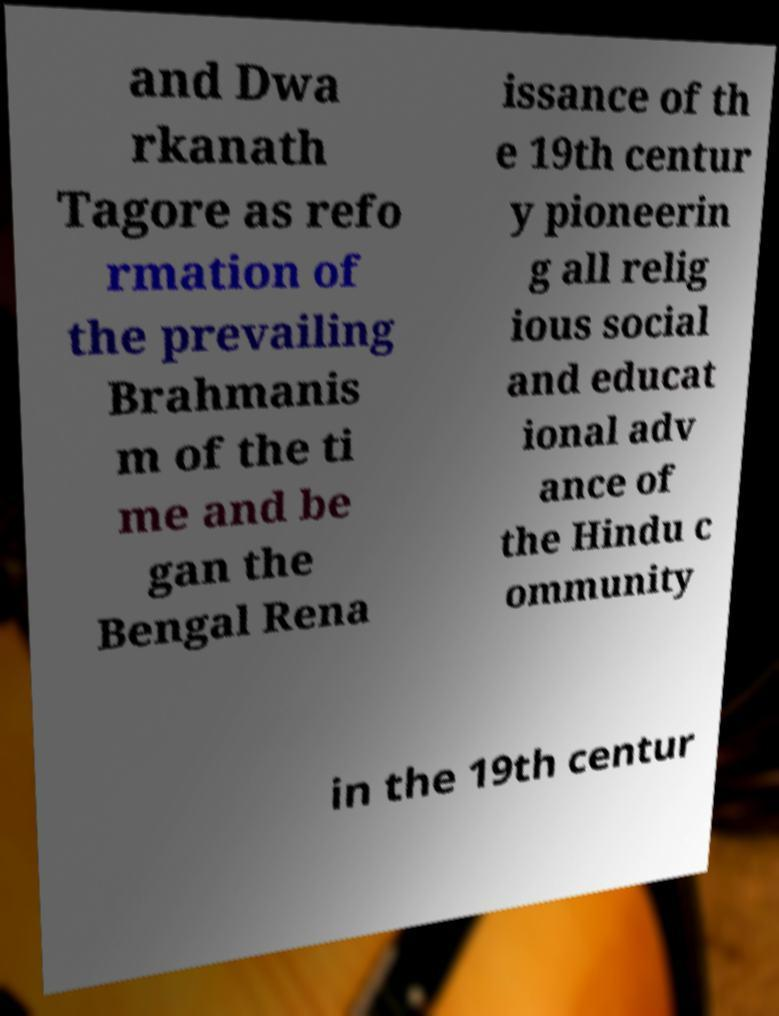Could you assist in decoding the text presented in this image and type it out clearly? and Dwa rkanath Tagore as refo rmation of the prevailing Brahmanis m of the ti me and be gan the Bengal Rena issance of th e 19th centur y pioneerin g all relig ious social and educat ional adv ance of the Hindu c ommunity in the 19th centur 